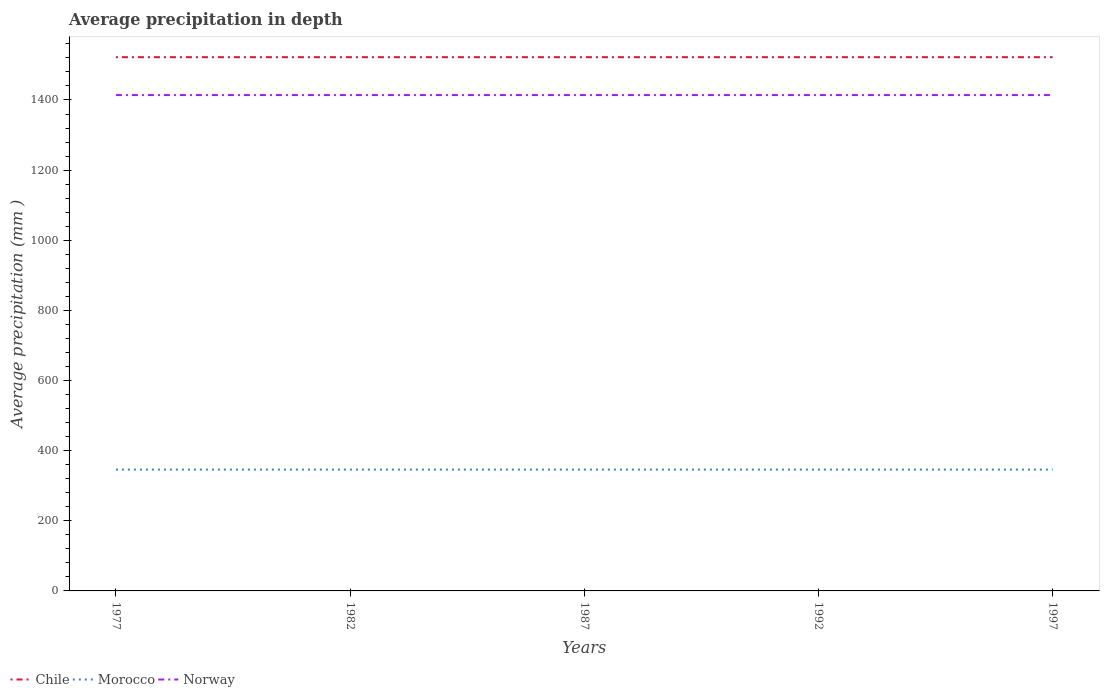Does the line corresponding to Chile intersect with the line corresponding to Morocco?
Ensure brevity in your answer.  No. Is the number of lines equal to the number of legend labels?
Provide a succinct answer. Yes. Across all years, what is the maximum average precipitation in Chile?
Your answer should be very brief. 1522. In which year was the average precipitation in Norway maximum?
Ensure brevity in your answer.  1977. What is the total average precipitation in Morocco in the graph?
Provide a succinct answer. 0. What is the difference between the highest and the lowest average precipitation in Norway?
Your answer should be compact. 0. Is the average precipitation in Chile strictly greater than the average precipitation in Morocco over the years?
Ensure brevity in your answer.  No. How many lines are there?
Provide a succinct answer. 3. What is the difference between two consecutive major ticks on the Y-axis?
Offer a very short reply. 200. Where does the legend appear in the graph?
Provide a short and direct response. Bottom left. How are the legend labels stacked?
Make the answer very short. Horizontal. What is the title of the graph?
Offer a very short reply. Average precipitation in depth. What is the label or title of the X-axis?
Your answer should be very brief. Years. What is the label or title of the Y-axis?
Ensure brevity in your answer.  Average precipitation (mm ). What is the Average precipitation (mm ) in Chile in 1977?
Make the answer very short. 1522. What is the Average precipitation (mm ) in Morocco in 1977?
Provide a succinct answer. 346. What is the Average precipitation (mm ) in Norway in 1977?
Provide a short and direct response. 1414. What is the Average precipitation (mm ) in Chile in 1982?
Your answer should be very brief. 1522. What is the Average precipitation (mm ) in Morocco in 1982?
Give a very brief answer. 346. What is the Average precipitation (mm ) in Norway in 1982?
Your answer should be compact. 1414. What is the Average precipitation (mm ) in Chile in 1987?
Ensure brevity in your answer.  1522. What is the Average precipitation (mm ) in Morocco in 1987?
Your answer should be very brief. 346. What is the Average precipitation (mm ) of Norway in 1987?
Make the answer very short. 1414. What is the Average precipitation (mm ) in Chile in 1992?
Keep it short and to the point. 1522. What is the Average precipitation (mm ) of Morocco in 1992?
Offer a terse response. 346. What is the Average precipitation (mm ) of Norway in 1992?
Offer a terse response. 1414. What is the Average precipitation (mm ) in Chile in 1997?
Your answer should be compact. 1522. What is the Average precipitation (mm ) of Morocco in 1997?
Offer a very short reply. 346. What is the Average precipitation (mm ) in Norway in 1997?
Provide a short and direct response. 1414. Across all years, what is the maximum Average precipitation (mm ) in Chile?
Your response must be concise. 1522. Across all years, what is the maximum Average precipitation (mm ) of Morocco?
Offer a terse response. 346. Across all years, what is the maximum Average precipitation (mm ) of Norway?
Offer a very short reply. 1414. Across all years, what is the minimum Average precipitation (mm ) in Chile?
Provide a succinct answer. 1522. Across all years, what is the minimum Average precipitation (mm ) of Morocco?
Your response must be concise. 346. Across all years, what is the minimum Average precipitation (mm ) of Norway?
Make the answer very short. 1414. What is the total Average precipitation (mm ) of Chile in the graph?
Your answer should be very brief. 7610. What is the total Average precipitation (mm ) in Morocco in the graph?
Keep it short and to the point. 1730. What is the total Average precipitation (mm ) of Norway in the graph?
Keep it short and to the point. 7070. What is the difference between the Average precipitation (mm ) of Morocco in 1977 and that in 1982?
Your answer should be very brief. 0. What is the difference between the Average precipitation (mm ) of Chile in 1977 and that in 1987?
Offer a very short reply. 0. What is the difference between the Average precipitation (mm ) of Norway in 1977 and that in 1987?
Provide a succinct answer. 0. What is the difference between the Average precipitation (mm ) in Chile in 1977 and that in 1992?
Keep it short and to the point. 0. What is the difference between the Average precipitation (mm ) of Morocco in 1977 and that in 1992?
Offer a very short reply. 0. What is the difference between the Average precipitation (mm ) of Morocco in 1977 and that in 1997?
Offer a very short reply. 0. What is the difference between the Average precipitation (mm ) of Chile in 1982 and that in 1987?
Your answer should be very brief. 0. What is the difference between the Average precipitation (mm ) of Norway in 1982 and that in 1987?
Provide a short and direct response. 0. What is the difference between the Average precipitation (mm ) in Chile in 1982 and that in 1992?
Offer a terse response. 0. What is the difference between the Average precipitation (mm ) in Chile in 1982 and that in 1997?
Ensure brevity in your answer.  0. What is the difference between the Average precipitation (mm ) of Norway in 1987 and that in 1992?
Your answer should be compact. 0. What is the difference between the Average precipitation (mm ) in Chile in 1987 and that in 1997?
Your answer should be compact. 0. What is the difference between the Average precipitation (mm ) of Norway in 1987 and that in 1997?
Give a very brief answer. 0. What is the difference between the Average precipitation (mm ) of Chile in 1992 and that in 1997?
Offer a very short reply. 0. What is the difference between the Average precipitation (mm ) of Morocco in 1992 and that in 1997?
Offer a terse response. 0. What is the difference between the Average precipitation (mm ) in Norway in 1992 and that in 1997?
Give a very brief answer. 0. What is the difference between the Average precipitation (mm ) of Chile in 1977 and the Average precipitation (mm ) of Morocco in 1982?
Offer a very short reply. 1176. What is the difference between the Average precipitation (mm ) in Chile in 1977 and the Average precipitation (mm ) in Norway in 1982?
Your answer should be very brief. 108. What is the difference between the Average precipitation (mm ) of Morocco in 1977 and the Average precipitation (mm ) of Norway in 1982?
Offer a very short reply. -1068. What is the difference between the Average precipitation (mm ) of Chile in 1977 and the Average precipitation (mm ) of Morocco in 1987?
Provide a short and direct response. 1176. What is the difference between the Average precipitation (mm ) in Chile in 1977 and the Average precipitation (mm ) in Norway in 1987?
Your answer should be compact. 108. What is the difference between the Average precipitation (mm ) in Morocco in 1977 and the Average precipitation (mm ) in Norway in 1987?
Make the answer very short. -1068. What is the difference between the Average precipitation (mm ) of Chile in 1977 and the Average precipitation (mm ) of Morocco in 1992?
Your answer should be very brief. 1176. What is the difference between the Average precipitation (mm ) of Chile in 1977 and the Average precipitation (mm ) of Norway in 1992?
Your answer should be very brief. 108. What is the difference between the Average precipitation (mm ) in Morocco in 1977 and the Average precipitation (mm ) in Norway in 1992?
Provide a succinct answer. -1068. What is the difference between the Average precipitation (mm ) in Chile in 1977 and the Average precipitation (mm ) in Morocco in 1997?
Your answer should be compact. 1176. What is the difference between the Average precipitation (mm ) in Chile in 1977 and the Average precipitation (mm ) in Norway in 1997?
Provide a succinct answer. 108. What is the difference between the Average precipitation (mm ) in Morocco in 1977 and the Average precipitation (mm ) in Norway in 1997?
Provide a short and direct response. -1068. What is the difference between the Average precipitation (mm ) in Chile in 1982 and the Average precipitation (mm ) in Morocco in 1987?
Offer a very short reply. 1176. What is the difference between the Average precipitation (mm ) of Chile in 1982 and the Average precipitation (mm ) of Norway in 1987?
Offer a terse response. 108. What is the difference between the Average precipitation (mm ) of Morocco in 1982 and the Average precipitation (mm ) of Norway in 1987?
Keep it short and to the point. -1068. What is the difference between the Average precipitation (mm ) in Chile in 1982 and the Average precipitation (mm ) in Morocco in 1992?
Your response must be concise. 1176. What is the difference between the Average precipitation (mm ) of Chile in 1982 and the Average precipitation (mm ) of Norway in 1992?
Provide a succinct answer. 108. What is the difference between the Average precipitation (mm ) in Morocco in 1982 and the Average precipitation (mm ) in Norway in 1992?
Keep it short and to the point. -1068. What is the difference between the Average precipitation (mm ) in Chile in 1982 and the Average precipitation (mm ) in Morocco in 1997?
Offer a very short reply. 1176. What is the difference between the Average precipitation (mm ) of Chile in 1982 and the Average precipitation (mm ) of Norway in 1997?
Give a very brief answer. 108. What is the difference between the Average precipitation (mm ) of Morocco in 1982 and the Average precipitation (mm ) of Norway in 1997?
Make the answer very short. -1068. What is the difference between the Average precipitation (mm ) in Chile in 1987 and the Average precipitation (mm ) in Morocco in 1992?
Provide a succinct answer. 1176. What is the difference between the Average precipitation (mm ) in Chile in 1987 and the Average precipitation (mm ) in Norway in 1992?
Provide a short and direct response. 108. What is the difference between the Average precipitation (mm ) in Morocco in 1987 and the Average precipitation (mm ) in Norway in 1992?
Offer a very short reply. -1068. What is the difference between the Average precipitation (mm ) in Chile in 1987 and the Average precipitation (mm ) in Morocco in 1997?
Ensure brevity in your answer.  1176. What is the difference between the Average precipitation (mm ) in Chile in 1987 and the Average precipitation (mm ) in Norway in 1997?
Your answer should be compact. 108. What is the difference between the Average precipitation (mm ) of Morocco in 1987 and the Average precipitation (mm ) of Norway in 1997?
Provide a short and direct response. -1068. What is the difference between the Average precipitation (mm ) in Chile in 1992 and the Average precipitation (mm ) in Morocco in 1997?
Give a very brief answer. 1176. What is the difference between the Average precipitation (mm ) of Chile in 1992 and the Average precipitation (mm ) of Norway in 1997?
Your answer should be very brief. 108. What is the difference between the Average precipitation (mm ) of Morocco in 1992 and the Average precipitation (mm ) of Norway in 1997?
Your response must be concise. -1068. What is the average Average precipitation (mm ) in Chile per year?
Provide a succinct answer. 1522. What is the average Average precipitation (mm ) of Morocco per year?
Ensure brevity in your answer.  346. What is the average Average precipitation (mm ) of Norway per year?
Ensure brevity in your answer.  1414. In the year 1977, what is the difference between the Average precipitation (mm ) of Chile and Average precipitation (mm ) of Morocco?
Ensure brevity in your answer.  1176. In the year 1977, what is the difference between the Average precipitation (mm ) of Chile and Average precipitation (mm ) of Norway?
Your answer should be compact. 108. In the year 1977, what is the difference between the Average precipitation (mm ) in Morocco and Average precipitation (mm ) in Norway?
Provide a short and direct response. -1068. In the year 1982, what is the difference between the Average precipitation (mm ) in Chile and Average precipitation (mm ) in Morocco?
Give a very brief answer. 1176. In the year 1982, what is the difference between the Average precipitation (mm ) in Chile and Average precipitation (mm ) in Norway?
Your response must be concise. 108. In the year 1982, what is the difference between the Average precipitation (mm ) of Morocco and Average precipitation (mm ) of Norway?
Keep it short and to the point. -1068. In the year 1987, what is the difference between the Average precipitation (mm ) in Chile and Average precipitation (mm ) in Morocco?
Offer a terse response. 1176. In the year 1987, what is the difference between the Average precipitation (mm ) of Chile and Average precipitation (mm ) of Norway?
Give a very brief answer. 108. In the year 1987, what is the difference between the Average precipitation (mm ) of Morocco and Average precipitation (mm ) of Norway?
Keep it short and to the point. -1068. In the year 1992, what is the difference between the Average precipitation (mm ) of Chile and Average precipitation (mm ) of Morocco?
Make the answer very short. 1176. In the year 1992, what is the difference between the Average precipitation (mm ) of Chile and Average precipitation (mm ) of Norway?
Offer a very short reply. 108. In the year 1992, what is the difference between the Average precipitation (mm ) of Morocco and Average precipitation (mm ) of Norway?
Ensure brevity in your answer.  -1068. In the year 1997, what is the difference between the Average precipitation (mm ) of Chile and Average precipitation (mm ) of Morocco?
Your answer should be compact. 1176. In the year 1997, what is the difference between the Average precipitation (mm ) of Chile and Average precipitation (mm ) of Norway?
Make the answer very short. 108. In the year 1997, what is the difference between the Average precipitation (mm ) of Morocco and Average precipitation (mm ) of Norway?
Your answer should be compact. -1068. What is the ratio of the Average precipitation (mm ) of Chile in 1977 to that in 1982?
Provide a succinct answer. 1. What is the ratio of the Average precipitation (mm ) of Morocco in 1977 to that in 1982?
Your answer should be very brief. 1. What is the ratio of the Average precipitation (mm ) in Morocco in 1977 to that in 1987?
Ensure brevity in your answer.  1. What is the ratio of the Average precipitation (mm ) of Norway in 1977 to that in 1987?
Make the answer very short. 1. What is the ratio of the Average precipitation (mm ) in Chile in 1977 to that in 1992?
Your answer should be compact. 1. What is the ratio of the Average precipitation (mm ) of Morocco in 1977 to that in 1992?
Ensure brevity in your answer.  1. What is the ratio of the Average precipitation (mm ) in Norway in 1977 to that in 1992?
Offer a terse response. 1. What is the ratio of the Average precipitation (mm ) of Morocco in 1977 to that in 1997?
Offer a terse response. 1. What is the ratio of the Average precipitation (mm ) in Norway in 1977 to that in 1997?
Your answer should be compact. 1. What is the ratio of the Average precipitation (mm ) in Chile in 1982 to that in 1987?
Provide a succinct answer. 1. What is the ratio of the Average precipitation (mm ) in Morocco in 1982 to that in 1987?
Your answer should be very brief. 1. What is the ratio of the Average precipitation (mm ) in Norway in 1982 to that in 1987?
Your answer should be very brief. 1. What is the ratio of the Average precipitation (mm ) of Norway in 1982 to that in 1992?
Provide a succinct answer. 1. What is the ratio of the Average precipitation (mm ) in Morocco in 1982 to that in 1997?
Provide a short and direct response. 1. What is the ratio of the Average precipitation (mm ) in Norway in 1982 to that in 1997?
Your answer should be very brief. 1. What is the ratio of the Average precipitation (mm ) in Chile in 1987 to that in 1997?
Give a very brief answer. 1. What is the ratio of the Average precipitation (mm ) in Morocco in 1987 to that in 1997?
Ensure brevity in your answer.  1. What is the ratio of the Average precipitation (mm ) of Norway in 1987 to that in 1997?
Make the answer very short. 1. What is the ratio of the Average precipitation (mm ) of Chile in 1992 to that in 1997?
Your response must be concise. 1. What is the ratio of the Average precipitation (mm ) in Norway in 1992 to that in 1997?
Offer a very short reply. 1. What is the difference between the highest and the second highest Average precipitation (mm ) of Chile?
Ensure brevity in your answer.  0. What is the difference between the highest and the second highest Average precipitation (mm ) of Norway?
Give a very brief answer. 0. What is the difference between the highest and the lowest Average precipitation (mm ) in Chile?
Give a very brief answer. 0. What is the difference between the highest and the lowest Average precipitation (mm ) in Morocco?
Provide a succinct answer. 0. What is the difference between the highest and the lowest Average precipitation (mm ) of Norway?
Offer a very short reply. 0. 